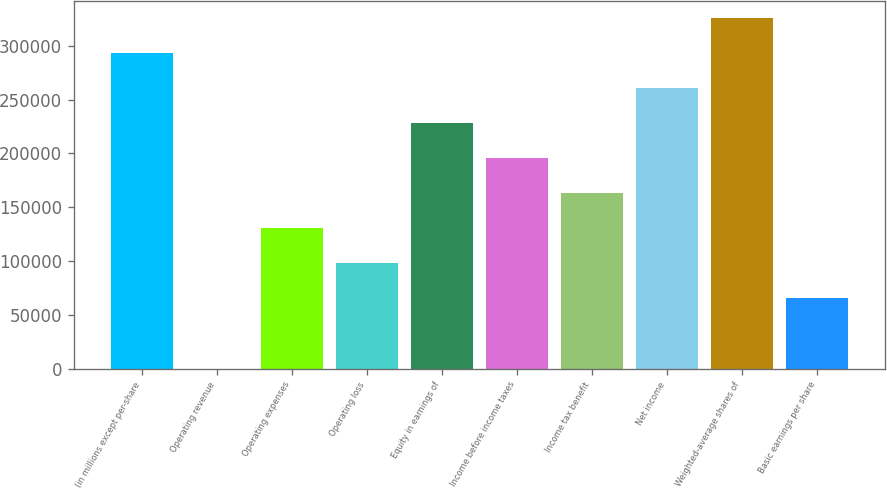Convert chart to OTSL. <chart><loc_0><loc_0><loc_500><loc_500><bar_chart><fcel>(in millions except per-share<fcel>Operating revenue<fcel>Operating expenses<fcel>Operating loss<fcel>Equity in earnings of<fcel>Income before income taxes<fcel>Income tax benefit<fcel>Net income<fcel>Weighted-average shares of<fcel>Basic earnings per share<nl><fcel>293230<fcel>1<fcel>130325<fcel>97744<fcel>228068<fcel>195487<fcel>162906<fcel>260649<fcel>325811<fcel>65163<nl></chart> 